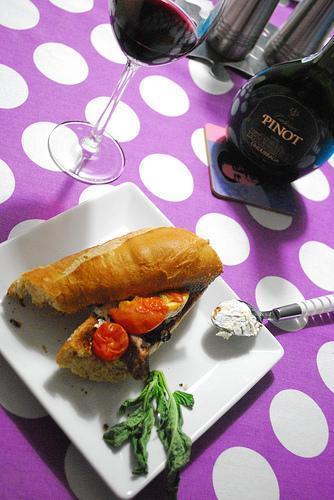How many sandwiches are there?
Give a very brief answer. 1. 